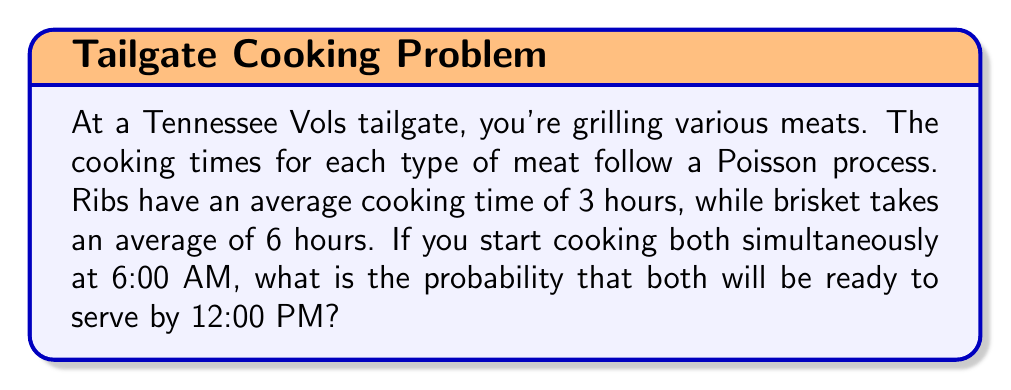Show me your answer to this math problem. Let's approach this step-by-step:

1) For a Poisson process, the time until an event occurs follows an exponential distribution. The parameter λ for the exponential distribution is the reciprocal of the average time.

2) For ribs: λ_ribs = 1/3 per hour
   For brisket: λ_brisket = 1/6 per hour

3) The probability that the cooking time is less than or equal to t hours is given by:
   P(T ≤ t) = 1 - e^(-λt)

4) The time from 6:00 AM to 12:00 PM is 6 hours.

5) For ribs:
   P(T_ribs ≤ 6) = 1 - e^(-(1/3) * 6) = 1 - e^(-2) ≈ 0.8647

6) For brisket:
   P(T_brisket ≤ 6) = 1 - e^(-(1/6) * 6) = 1 - e^(-1) ≈ 0.6321

7) The probability that both are ready is the product of their individual probabilities:

   P(both ready) = P(T_ribs ≤ 6) * P(T_brisket ≤ 6)
                 ≈ 0.8647 * 0.6321
                 ≈ 0.5466

Therefore, the probability that both the ribs and brisket will be ready to serve by 12:00 PM is approximately 0.5466 or 54.66%.
Answer: 0.5466 